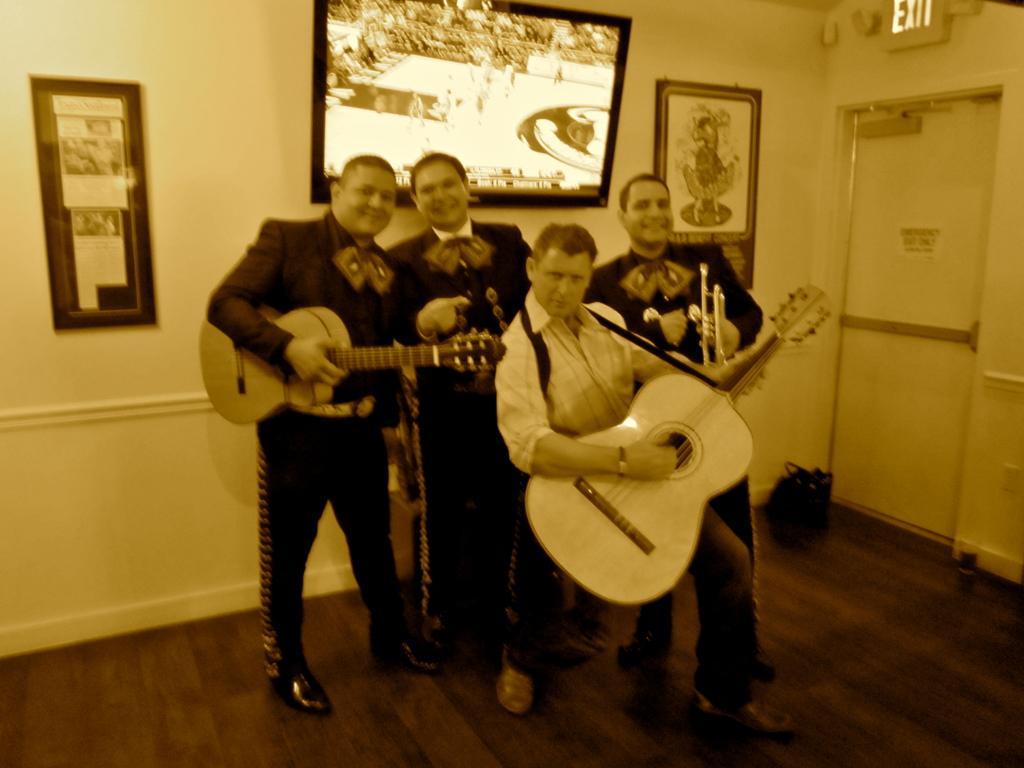How would you summarize this image in a sentence or two? In this image i can see 4 persons standing and holding musical instruments in their hands, all of them are wearing shoes. In the background i can see the wall, 2 photo frame, a door, a sign board and a television. 